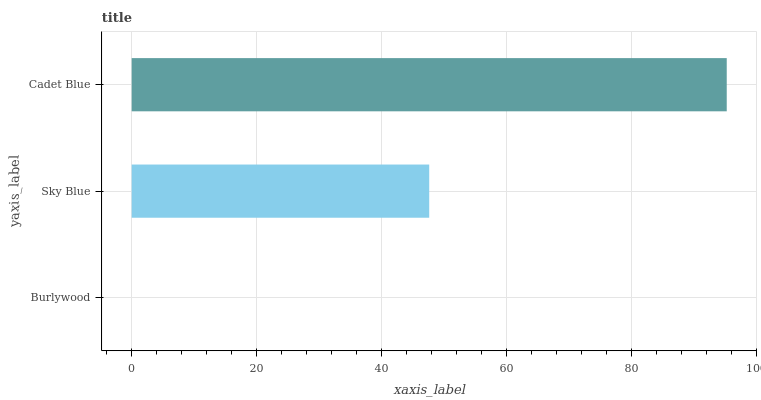Is Burlywood the minimum?
Answer yes or no. Yes. Is Cadet Blue the maximum?
Answer yes or no. Yes. Is Sky Blue the minimum?
Answer yes or no. No. Is Sky Blue the maximum?
Answer yes or no. No. Is Sky Blue greater than Burlywood?
Answer yes or no. Yes. Is Burlywood less than Sky Blue?
Answer yes or no. Yes. Is Burlywood greater than Sky Blue?
Answer yes or no. No. Is Sky Blue less than Burlywood?
Answer yes or no. No. Is Sky Blue the high median?
Answer yes or no. Yes. Is Sky Blue the low median?
Answer yes or no. Yes. Is Burlywood the high median?
Answer yes or no. No. Is Cadet Blue the low median?
Answer yes or no. No. 